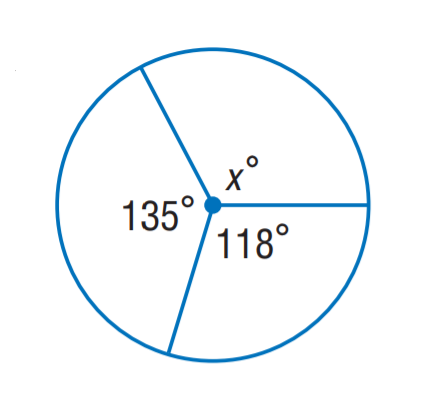Question: Find x.
Choices:
A. 107
B. 117
C. 118
D. 135
Answer with the letter. Answer: A 